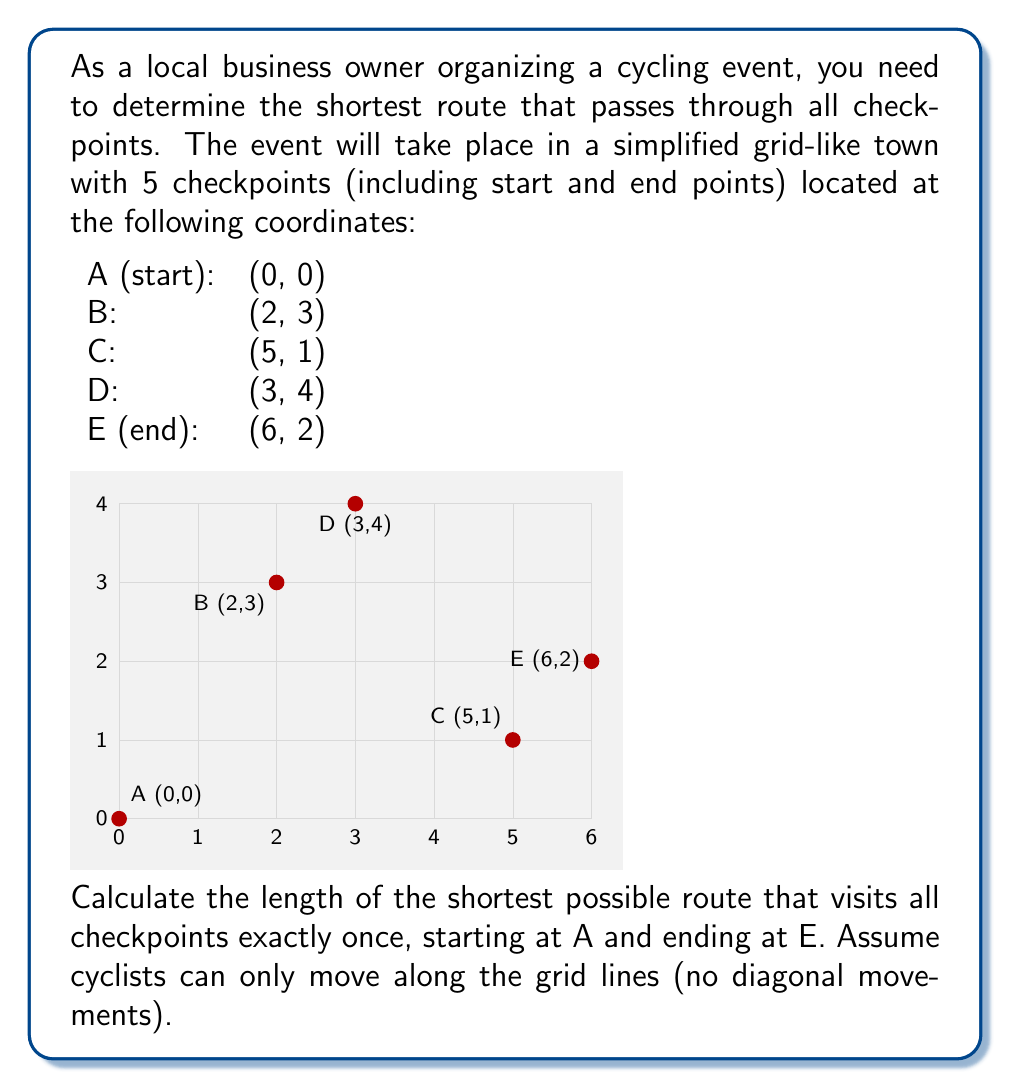What is the answer to this math problem? To solve this problem, we need to find the shortest path that visits all checkpoints in the most efficient order. This is a variation of the Traveling Salesman Problem. Given the grid-like structure and the small number of points, we can solve this by considering all possible routes and calculating their lengths.

Step 1: List all possible routes
There are 6 possible routes:
1. A → B → C → D → E
2. A → B → D → C → E
3. A → C → B → D → E
4. A → C → D → B → E
5. A → D → B → C → E
6. A → D → C → B → E

Step 2: Calculate the length of each route
Let's calculate the Manhattan distance between each pair of points:
A to B: |0-2| + |0-3| = 5
A to C: |0-5| + |0-1| = 6
A to D: |0-3| + |0-4| = 7
B to C: |2-5| + |3-1| = 5
B to D: |2-3| + |3-4| = 2
C to D: |5-3| + |1-4| = 5
C to E: |5-6| + |1-2| = 2
D to E: |3-6| + |4-2| = 5

Now, let's calculate the total length for each route:

1. A → B → C → D → E: 5 + 5 + 5 + 5 = 20
2. A → B → D → C → E: 5 + 2 + 5 + 2 = 14
3. A → C → B → D → E: 6 + 5 + 2 + 5 = 18
4. A → C → D → B → E: 6 + 5 + 2 + 4 = 17
5. A → D → B → C → E: 7 + 2 + 5 + 2 = 16
6. A → D → C → B → E: 7 + 5 + 5 + 4 = 21

Step 3: Identify the shortest route
The shortest route is option 2: A → B → D → C → E, with a total length of 14 units.
Answer: 14 units 